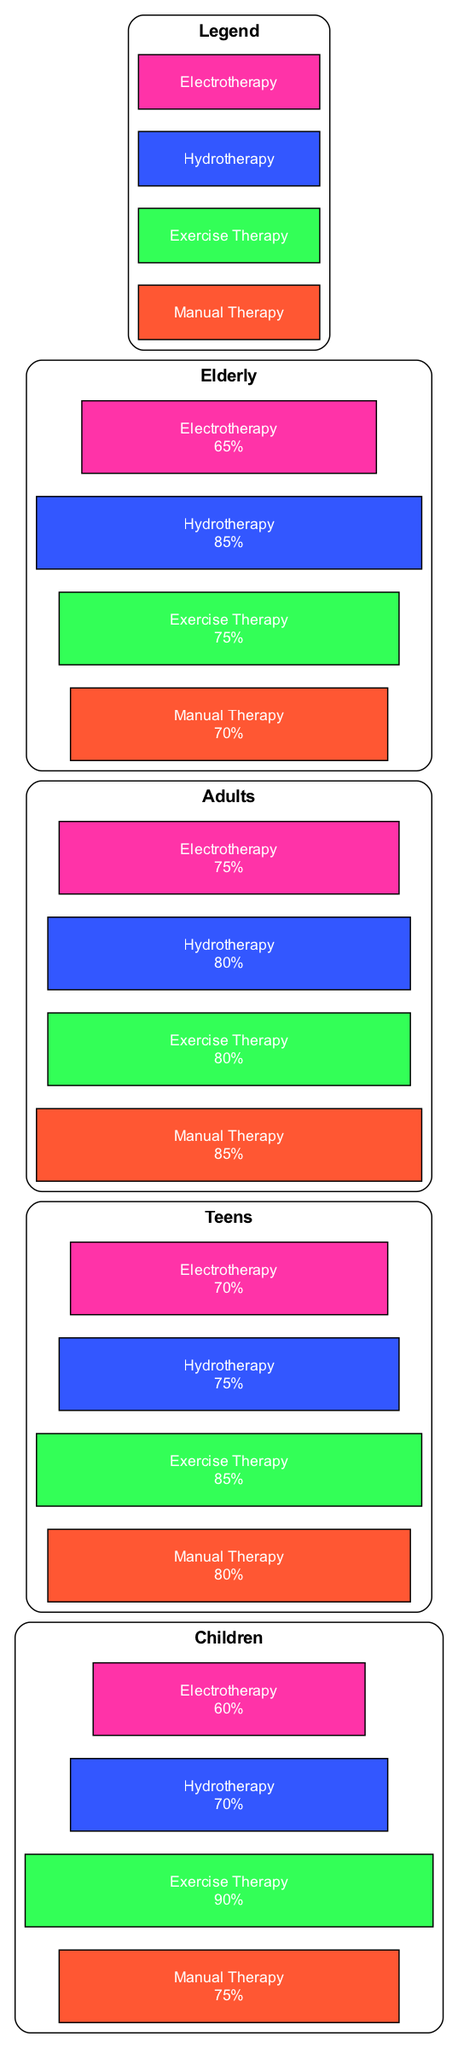What is the effectiveness of Manual Therapy for Children? The effectiveness value for Manual Therapy in the Children category is shown in the diagram. By checking this specific node, we see it indicates a value of 75%.
Answer: 75% Which physiotherapy technique is most effective for Teens? Looking at the Teen category, we compare the effectiveness values of each physiotherapy technique. Exercise Therapy has the highest effectiveness value of 85%.
Answer: Exercise Therapy How many techniques are compared in total? The diagram includes a list of four different physiotherapy techniques. Counting these, we find that there are four: Manual Therapy, Exercise Therapy, Hydrotherapy, and Electrotherapy.
Answer: 4 What is the effectiveness percentage of Hydrotherapy for the Elderly? We find the effectiveness node for Hydrotherapy under the Elderly category in the diagram. The displayed value indicates an effectiveness of 85%.
Answer: 85% Which technique shows the least effectiveness in the Children's group? To determine the least effective technique for Children, we compare the effectiveness values from that age group. Electrotherapy shows the lowest effectiveness value of 60%.
Answer: Electrotherapy Is the effectiveness of Exercise Therapy higher for Adults or Teens? By comparing the effectiveness values of Exercise Therapy for both age groups—80% for Adults and 85% for Teens—we can conclude that it is higher for Teens with a value of 85%.
Answer: Teens What color represents Hydrotherapy in the diagram? Each physiotherapy technique has a corresponding color clearly indicated in the legend. Hydrotherapy is represented by the color blue (#3357FF).
Answer: Blue Which age group has the highest effectiveness percentage for Exercise Therapy? We examine the Exercise Therapy effectiveness values across all age groups. The Children category shows the highest effectiveness at 90%.
Answer: Children What is the difference in effectiveness between Adults and Elderly for Manual Therapy? We look at the effectiveness values for both age groups under Manual Therapy. Adults have a value of 85% while Elderly have a value of 70%, resulting in a difference of 15%.
Answer: 15% 